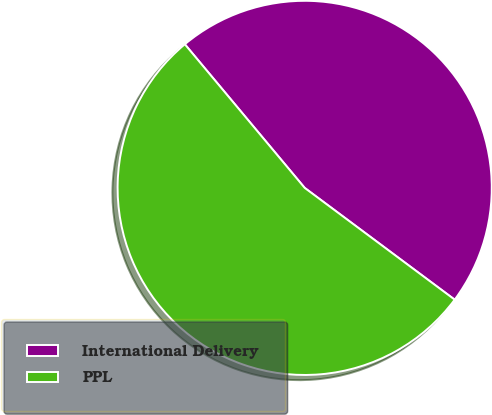Convert chart. <chart><loc_0><loc_0><loc_500><loc_500><pie_chart><fcel>International Delivery<fcel>PPL<nl><fcel>46.26%<fcel>53.74%<nl></chart> 